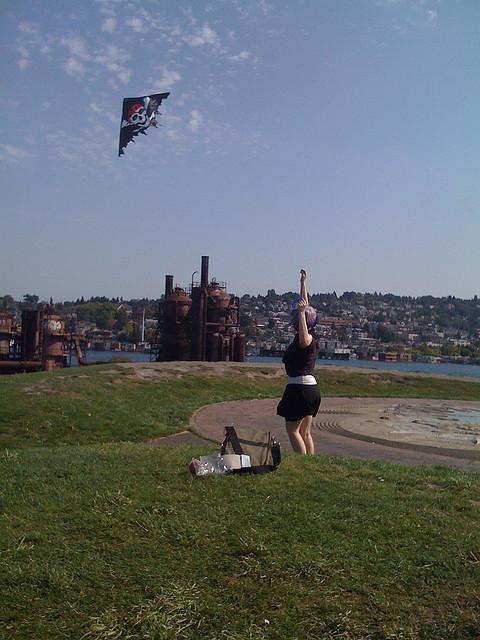How does the woman direct here kite and control it?
Pick the correct solution from the four options below to address the question.
Options: Magic, drone, string, wand. String. 